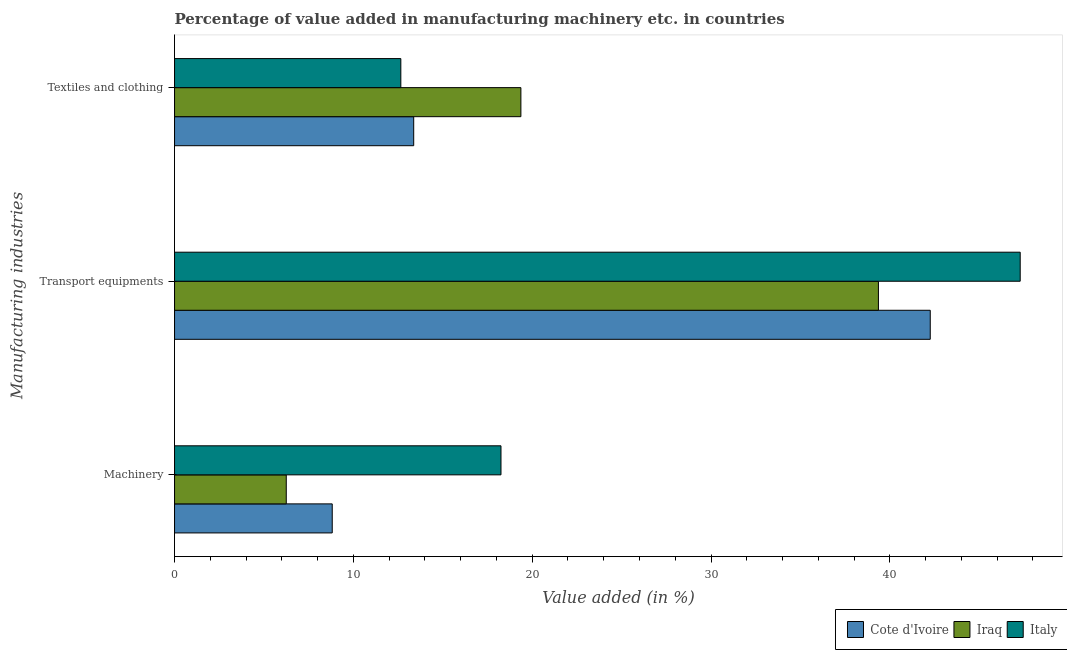How many groups of bars are there?
Keep it short and to the point. 3. Are the number of bars on each tick of the Y-axis equal?
Ensure brevity in your answer.  Yes. What is the label of the 3rd group of bars from the top?
Your answer should be very brief. Machinery. What is the value added in manufacturing textile and clothing in Cote d'Ivoire?
Keep it short and to the point. 13.37. Across all countries, what is the maximum value added in manufacturing transport equipments?
Offer a very short reply. 47.29. Across all countries, what is the minimum value added in manufacturing transport equipments?
Offer a very short reply. 39.36. In which country was the value added in manufacturing textile and clothing maximum?
Provide a succinct answer. Iraq. In which country was the value added in manufacturing textile and clothing minimum?
Provide a succinct answer. Italy. What is the total value added in manufacturing machinery in the graph?
Your response must be concise. 33.32. What is the difference between the value added in manufacturing machinery in Italy and that in Cote d'Ivoire?
Your answer should be compact. 9.44. What is the difference between the value added in manufacturing textile and clothing in Cote d'Ivoire and the value added in manufacturing transport equipments in Iraq?
Your answer should be compact. -25.99. What is the average value added in manufacturing textile and clothing per country?
Your answer should be very brief. 15.13. What is the difference between the value added in manufacturing transport equipments and value added in manufacturing textile and clothing in Cote d'Ivoire?
Make the answer very short. 28.88. What is the ratio of the value added in manufacturing machinery in Iraq to that in Italy?
Make the answer very short. 0.34. Is the value added in manufacturing machinery in Iraq less than that in Cote d'Ivoire?
Give a very brief answer. Yes. What is the difference between the highest and the second highest value added in manufacturing transport equipments?
Make the answer very short. 5.03. What is the difference between the highest and the lowest value added in manufacturing textile and clothing?
Provide a succinct answer. 6.71. In how many countries, is the value added in manufacturing machinery greater than the average value added in manufacturing machinery taken over all countries?
Offer a terse response. 1. Is the sum of the value added in manufacturing textile and clothing in Italy and Cote d'Ivoire greater than the maximum value added in manufacturing machinery across all countries?
Offer a terse response. Yes. What does the 2nd bar from the top in Textiles and clothing represents?
Your answer should be very brief. Iraq. What does the 3rd bar from the bottom in Machinery represents?
Your answer should be compact. Italy. Is it the case that in every country, the sum of the value added in manufacturing machinery and value added in manufacturing transport equipments is greater than the value added in manufacturing textile and clothing?
Provide a succinct answer. Yes. How many countries are there in the graph?
Provide a succinct answer. 3. Does the graph contain any zero values?
Give a very brief answer. No. Does the graph contain grids?
Provide a short and direct response. No. Where does the legend appear in the graph?
Your answer should be compact. Bottom right. How are the legend labels stacked?
Give a very brief answer. Horizontal. What is the title of the graph?
Offer a very short reply. Percentage of value added in manufacturing machinery etc. in countries. What is the label or title of the X-axis?
Keep it short and to the point. Value added (in %). What is the label or title of the Y-axis?
Provide a succinct answer. Manufacturing industries. What is the Value added (in %) of Cote d'Ivoire in Machinery?
Offer a terse response. 8.82. What is the Value added (in %) of Iraq in Machinery?
Offer a very short reply. 6.25. What is the Value added (in %) of Italy in Machinery?
Provide a succinct answer. 18.25. What is the Value added (in %) of Cote d'Ivoire in Transport equipments?
Make the answer very short. 42.26. What is the Value added (in %) in Iraq in Transport equipments?
Provide a short and direct response. 39.36. What is the Value added (in %) of Italy in Transport equipments?
Your response must be concise. 47.29. What is the Value added (in %) in Cote d'Ivoire in Textiles and clothing?
Give a very brief answer. 13.37. What is the Value added (in %) of Iraq in Textiles and clothing?
Make the answer very short. 19.37. What is the Value added (in %) in Italy in Textiles and clothing?
Your response must be concise. 12.65. Across all Manufacturing industries, what is the maximum Value added (in %) of Cote d'Ivoire?
Make the answer very short. 42.26. Across all Manufacturing industries, what is the maximum Value added (in %) of Iraq?
Your response must be concise. 39.36. Across all Manufacturing industries, what is the maximum Value added (in %) in Italy?
Provide a succinct answer. 47.29. Across all Manufacturing industries, what is the minimum Value added (in %) in Cote d'Ivoire?
Your response must be concise. 8.82. Across all Manufacturing industries, what is the minimum Value added (in %) of Iraq?
Your response must be concise. 6.25. Across all Manufacturing industries, what is the minimum Value added (in %) of Italy?
Provide a succinct answer. 12.65. What is the total Value added (in %) in Cote d'Ivoire in the graph?
Your answer should be compact. 64.45. What is the total Value added (in %) in Iraq in the graph?
Offer a terse response. 64.97. What is the total Value added (in %) of Italy in the graph?
Give a very brief answer. 78.2. What is the difference between the Value added (in %) in Cote d'Ivoire in Machinery and that in Transport equipments?
Offer a very short reply. -33.44. What is the difference between the Value added (in %) of Iraq in Machinery and that in Transport equipments?
Offer a very short reply. -33.11. What is the difference between the Value added (in %) in Italy in Machinery and that in Transport equipments?
Ensure brevity in your answer.  -29.03. What is the difference between the Value added (in %) in Cote d'Ivoire in Machinery and that in Textiles and clothing?
Offer a very short reply. -4.56. What is the difference between the Value added (in %) of Iraq in Machinery and that in Textiles and clothing?
Offer a very short reply. -13.12. What is the difference between the Value added (in %) of Italy in Machinery and that in Textiles and clothing?
Your answer should be compact. 5.6. What is the difference between the Value added (in %) in Cote d'Ivoire in Transport equipments and that in Textiles and clothing?
Make the answer very short. 28.88. What is the difference between the Value added (in %) in Iraq in Transport equipments and that in Textiles and clothing?
Ensure brevity in your answer.  19.99. What is the difference between the Value added (in %) of Italy in Transport equipments and that in Textiles and clothing?
Offer a very short reply. 34.63. What is the difference between the Value added (in %) in Cote d'Ivoire in Machinery and the Value added (in %) in Iraq in Transport equipments?
Provide a short and direct response. -30.54. What is the difference between the Value added (in %) in Cote d'Ivoire in Machinery and the Value added (in %) in Italy in Transport equipments?
Make the answer very short. -38.47. What is the difference between the Value added (in %) of Iraq in Machinery and the Value added (in %) of Italy in Transport equipments?
Give a very brief answer. -41.04. What is the difference between the Value added (in %) in Cote d'Ivoire in Machinery and the Value added (in %) in Iraq in Textiles and clothing?
Your answer should be very brief. -10.55. What is the difference between the Value added (in %) in Cote d'Ivoire in Machinery and the Value added (in %) in Italy in Textiles and clothing?
Your answer should be compact. -3.84. What is the difference between the Value added (in %) in Iraq in Machinery and the Value added (in %) in Italy in Textiles and clothing?
Your response must be concise. -6.41. What is the difference between the Value added (in %) in Cote d'Ivoire in Transport equipments and the Value added (in %) in Iraq in Textiles and clothing?
Offer a terse response. 22.89. What is the difference between the Value added (in %) of Cote d'Ivoire in Transport equipments and the Value added (in %) of Italy in Textiles and clothing?
Provide a succinct answer. 29.6. What is the difference between the Value added (in %) of Iraq in Transport equipments and the Value added (in %) of Italy in Textiles and clothing?
Give a very brief answer. 26.71. What is the average Value added (in %) in Cote d'Ivoire per Manufacturing industries?
Offer a very short reply. 21.48. What is the average Value added (in %) in Iraq per Manufacturing industries?
Offer a very short reply. 21.66. What is the average Value added (in %) of Italy per Manufacturing industries?
Ensure brevity in your answer.  26.07. What is the difference between the Value added (in %) of Cote d'Ivoire and Value added (in %) of Iraq in Machinery?
Your answer should be very brief. 2.57. What is the difference between the Value added (in %) of Cote d'Ivoire and Value added (in %) of Italy in Machinery?
Your answer should be very brief. -9.44. What is the difference between the Value added (in %) in Iraq and Value added (in %) in Italy in Machinery?
Ensure brevity in your answer.  -12.01. What is the difference between the Value added (in %) of Cote d'Ivoire and Value added (in %) of Iraq in Transport equipments?
Ensure brevity in your answer.  2.9. What is the difference between the Value added (in %) of Cote d'Ivoire and Value added (in %) of Italy in Transport equipments?
Your response must be concise. -5.03. What is the difference between the Value added (in %) of Iraq and Value added (in %) of Italy in Transport equipments?
Offer a terse response. -7.93. What is the difference between the Value added (in %) in Cote d'Ivoire and Value added (in %) in Iraq in Textiles and clothing?
Your response must be concise. -5.99. What is the difference between the Value added (in %) in Cote d'Ivoire and Value added (in %) in Italy in Textiles and clothing?
Keep it short and to the point. 0.72. What is the difference between the Value added (in %) of Iraq and Value added (in %) of Italy in Textiles and clothing?
Offer a terse response. 6.71. What is the ratio of the Value added (in %) of Cote d'Ivoire in Machinery to that in Transport equipments?
Offer a very short reply. 0.21. What is the ratio of the Value added (in %) in Iraq in Machinery to that in Transport equipments?
Make the answer very short. 0.16. What is the ratio of the Value added (in %) of Italy in Machinery to that in Transport equipments?
Give a very brief answer. 0.39. What is the ratio of the Value added (in %) of Cote d'Ivoire in Machinery to that in Textiles and clothing?
Offer a terse response. 0.66. What is the ratio of the Value added (in %) of Iraq in Machinery to that in Textiles and clothing?
Keep it short and to the point. 0.32. What is the ratio of the Value added (in %) of Italy in Machinery to that in Textiles and clothing?
Make the answer very short. 1.44. What is the ratio of the Value added (in %) of Cote d'Ivoire in Transport equipments to that in Textiles and clothing?
Offer a terse response. 3.16. What is the ratio of the Value added (in %) in Iraq in Transport equipments to that in Textiles and clothing?
Make the answer very short. 2.03. What is the ratio of the Value added (in %) of Italy in Transport equipments to that in Textiles and clothing?
Your answer should be compact. 3.74. What is the difference between the highest and the second highest Value added (in %) of Cote d'Ivoire?
Ensure brevity in your answer.  28.88. What is the difference between the highest and the second highest Value added (in %) in Iraq?
Keep it short and to the point. 19.99. What is the difference between the highest and the second highest Value added (in %) in Italy?
Your response must be concise. 29.03. What is the difference between the highest and the lowest Value added (in %) of Cote d'Ivoire?
Keep it short and to the point. 33.44. What is the difference between the highest and the lowest Value added (in %) of Iraq?
Your answer should be very brief. 33.11. What is the difference between the highest and the lowest Value added (in %) in Italy?
Provide a short and direct response. 34.63. 